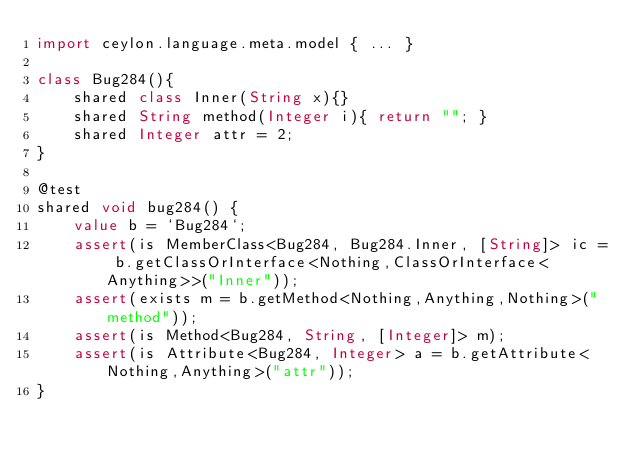Convert code to text. <code><loc_0><loc_0><loc_500><loc_500><_Ceylon_>import ceylon.language.meta.model { ... }

class Bug284(){
    shared class Inner(String x){}
    shared String method(Integer i){ return ""; }
    shared Integer attr = 2;
}

@test
shared void bug284() {
    value b = `Bug284`;
    assert(is MemberClass<Bug284, Bug284.Inner, [String]> ic = b.getClassOrInterface<Nothing,ClassOrInterface<Anything>>("Inner"));
    assert(exists m = b.getMethod<Nothing,Anything,Nothing>("method"));
    assert(is Method<Bug284, String, [Integer]> m);
    assert(is Attribute<Bug284, Integer> a = b.getAttribute<Nothing,Anything>("attr"));
}</code> 